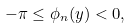<formula> <loc_0><loc_0><loc_500><loc_500>- \pi \leq \phi _ { n } ( y ) < 0 ,</formula> 